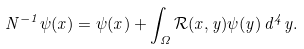<formula> <loc_0><loc_0><loc_500><loc_500>N ^ { - 1 } \psi ( x ) = \psi ( x ) + \int _ { \Omega } \mathcal { R } ( x , y ) \psi ( y ) \, d ^ { 4 } y .</formula> 